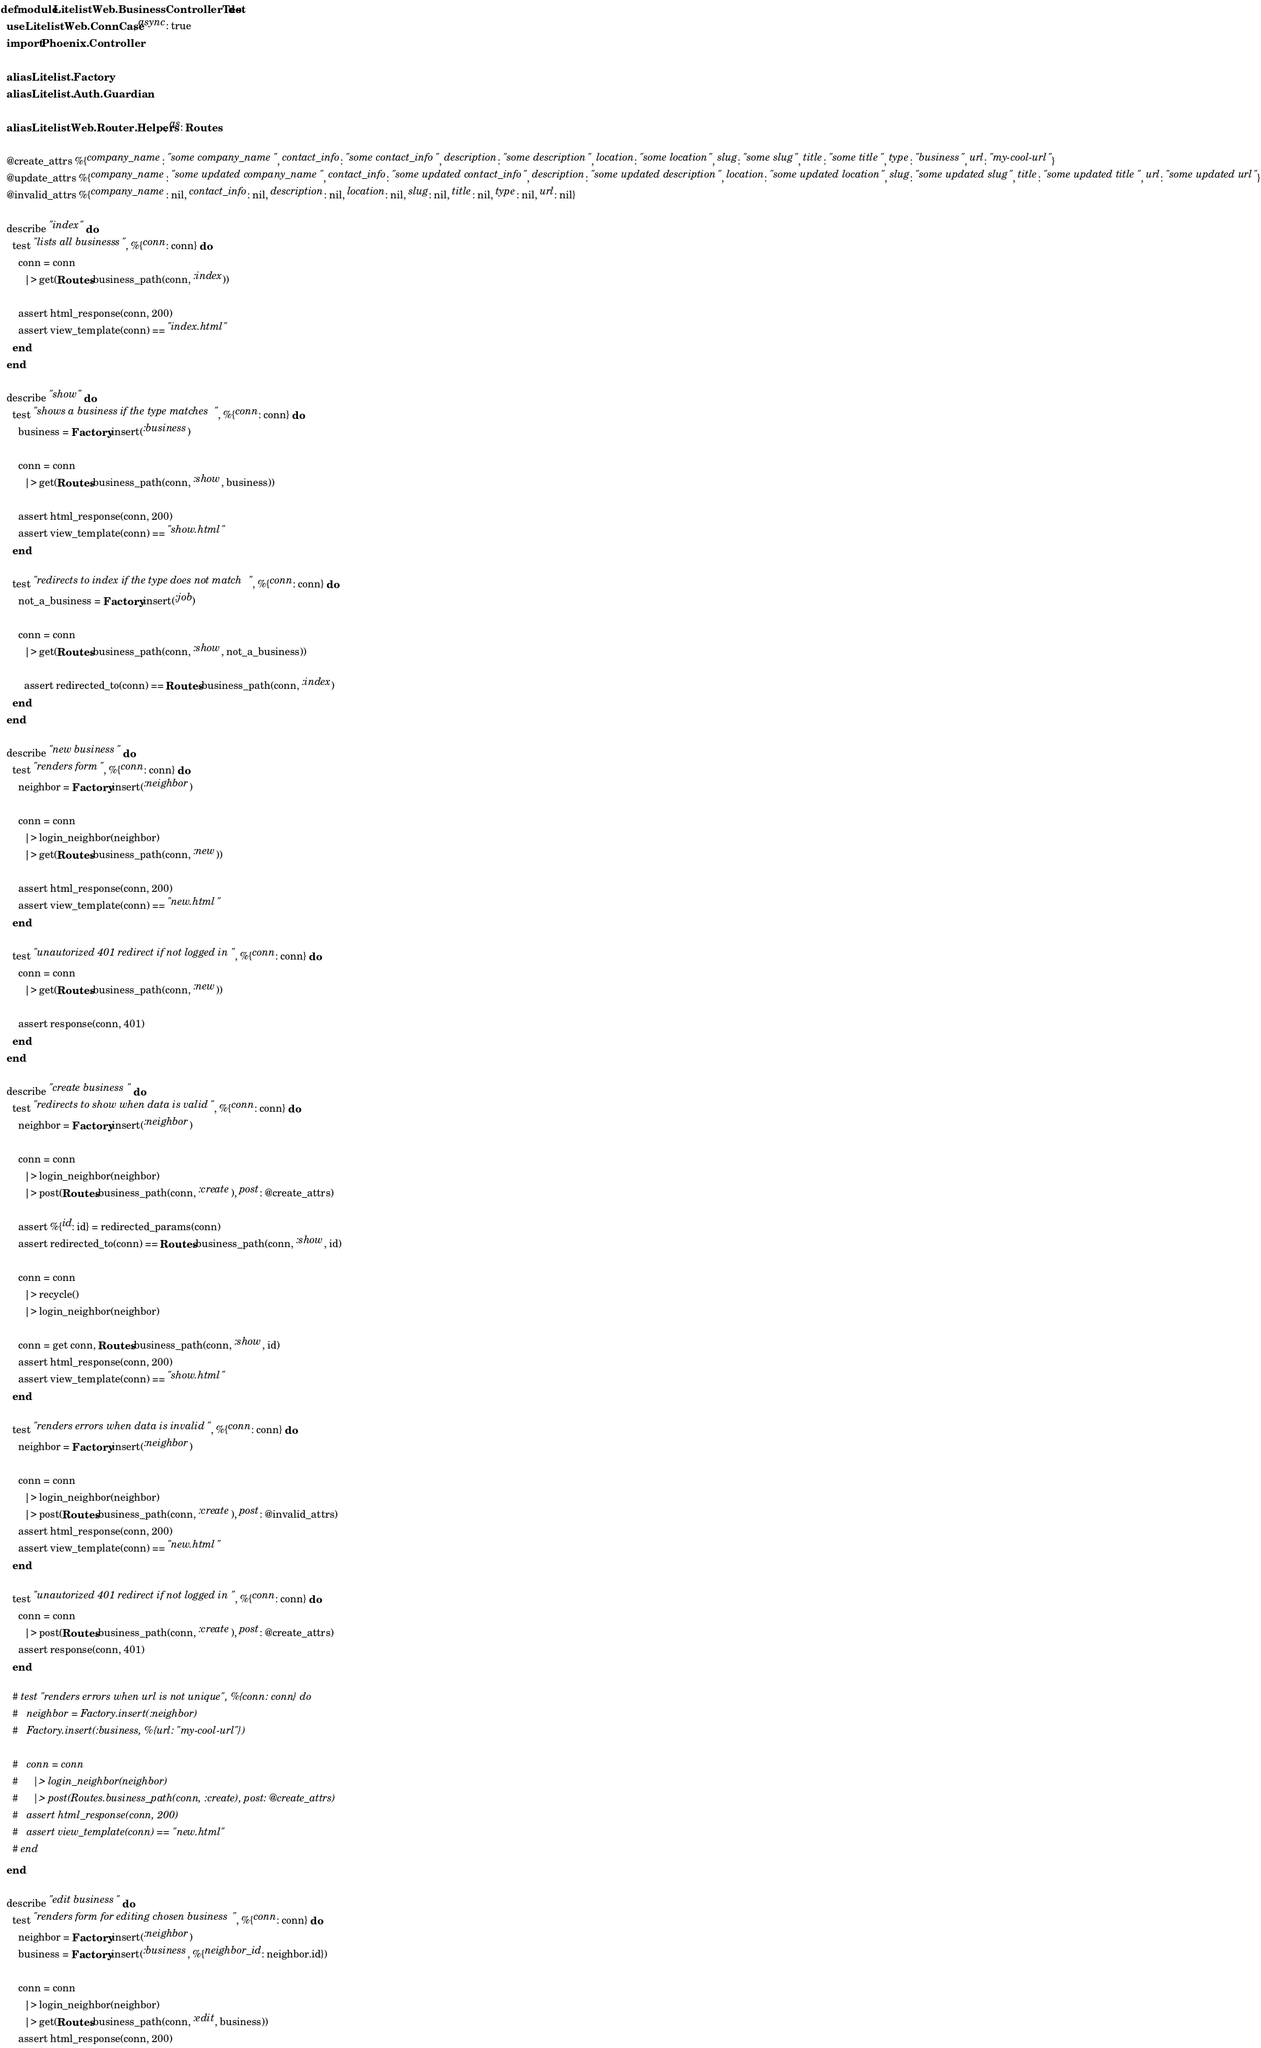<code> <loc_0><loc_0><loc_500><loc_500><_Elixir_>defmodule LitelistWeb.BusinessControllerTest do
  use LitelistWeb.ConnCase, async: true
  import Phoenix.Controller

  alias Litelist.Factory
  alias Litelist.Auth.Guardian

  alias LitelistWeb.Router.Helpers, as: Routes

  @create_attrs %{company_name: "some company_name", contact_info: "some contact_info", description: "some description", location: "some location", slug: "some slug", title: "some title", type: "business", url: "my-cool-url"}
  @update_attrs %{company_name: "some updated company_name", contact_info: "some updated contact_info", description: "some updated description", location: "some updated location", slug: "some updated slug", title: "some updated title", url: "some updated url"}
  @invalid_attrs %{company_name: nil, contact_info: nil, description: nil, location: nil, slug: nil, title: nil, type: nil, url: nil}

  describe "index" do
    test "lists all businesss", %{conn: conn} do
      conn = conn
        |> get(Routes.business_path(conn, :index))

      assert html_response(conn, 200)
      assert view_template(conn) == "index.html"
    end
  end

  describe "show" do
    test "shows a business if the type matches", %{conn: conn} do
      business = Factory.insert(:business)

      conn = conn
        |> get(Routes.business_path(conn, :show, business))

      assert html_response(conn, 200)
      assert view_template(conn) == "show.html"
    end

    test "redirects to index if the type does not match", %{conn: conn} do
      not_a_business = Factory.insert(:job)

      conn = conn
        |> get(Routes.business_path(conn, :show, not_a_business))

        assert redirected_to(conn) == Routes.business_path(conn, :index)
    end
  end

  describe "new business" do
    test "renders form", %{conn: conn} do
      neighbor = Factory.insert(:neighbor)

      conn = conn
        |> login_neighbor(neighbor)
        |> get(Routes.business_path(conn, :new))
      
      assert html_response(conn, 200)
      assert view_template(conn) == "new.html"
    end

    test "unautorized 401 redirect if not logged in", %{conn: conn} do
      conn = conn
        |> get(Routes.business_path(conn, :new))
      
      assert response(conn, 401)
    end
  end
  
  describe "create business" do
    test "redirects to show when data is valid", %{conn: conn} do
      neighbor = Factory.insert(:neighbor)

      conn = conn
        |> login_neighbor(neighbor)
        |> post(Routes.business_path(conn, :create), post: @create_attrs)

      assert %{id: id} = redirected_params(conn)
      assert redirected_to(conn) == Routes.business_path(conn, :show, id)

      conn = conn
        |> recycle()
        |> login_neighbor(neighbor)

      conn = get conn, Routes.business_path(conn, :show, id)
      assert html_response(conn, 200)
      assert view_template(conn) == "show.html"
    end

    test "renders errors when data is invalid", %{conn: conn} do
      neighbor = Factory.insert(:neighbor)

      conn = conn
        |> login_neighbor(neighbor)
        |> post(Routes.business_path(conn, :create), post: @invalid_attrs)
      assert html_response(conn, 200)
      assert view_template(conn) == "new.html"
    end

    test "unautorized 401 redirect if not logged in", %{conn: conn} do
      conn = conn
        |> post(Routes.business_path(conn, :create), post: @create_attrs)
      assert response(conn, 401)
    end

    # test "renders errors when url is not unique", %{conn: conn} do
    #   neighbor = Factory.insert(:neighbor)
    #   Factory.insert(:business, %{url: "my-cool-url"})

    #   conn = conn
    #     |> login_neighbor(neighbor)
    #     |> post(Routes.business_path(conn, :create), post: @create_attrs)
    #   assert html_response(conn, 200)
    #   assert view_template(conn) == "new.html"
    # end
  end

  describe "edit business" do
    test "renders form for editing chosen business", %{conn: conn} do
      neighbor = Factory.insert(:neighbor)
      business = Factory.insert(:business, %{neighbor_id: neighbor.id})

      conn = conn
        |> login_neighbor(neighbor)
        |> get(Routes.business_path(conn, :edit, business))
      assert html_response(conn, 200)</code> 